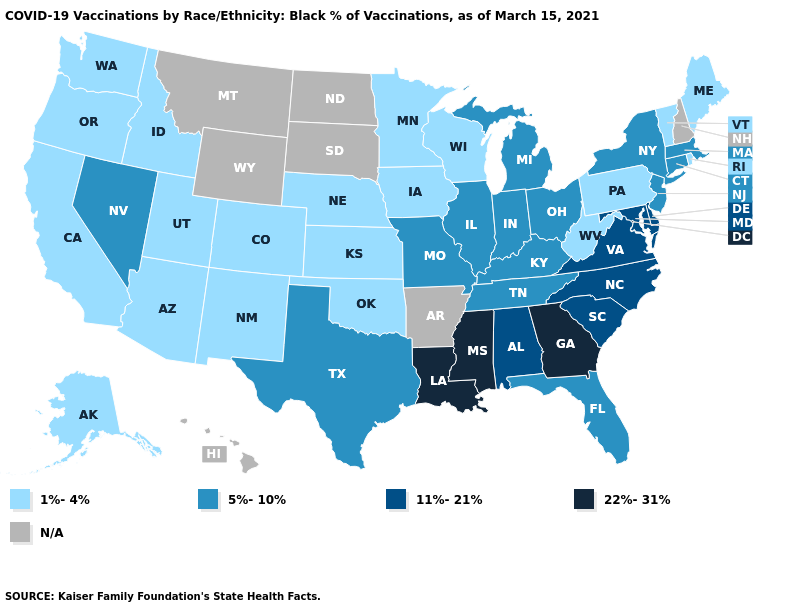Among the states that border Iowa , does Missouri have the highest value?
Keep it brief. Yes. What is the highest value in the USA?
Write a very short answer. 22%-31%. Does Arizona have the highest value in the USA?
Be succinct. No. Does Illinois have the lowest value in the MidWest?
Answer briefly. No. How many symbols are there in the legend?
Give a very brief answer. 5. What is the value of New Mexico?
Concise answer only. 1%-4%. Name the states that have a value in the range 11%-21%?
Concise answer only. Alabama, Delaware, Maryland, North Carolina, South Carolina, Virginia. What is the highest value in states that border Arizona?
Concise answer only. 5%-10%. Does Tennessee have the lowest value in the USA?
Concise answer only. No. How many symbols are there in the legend?
Answer briefly. 5. What is the lowest value in the MidWest?
Be succinct. 1%-4%. Does Mississippi have the highest value in the USA?
Be succinct. Yes. What is the highest value in the South ?
Short answer required. 22%-31%. What is the lowest value in states that border Oregon?
Give a very brief answer. 1%-4%. What is the value of Vermont?
Answer briefly. 1%-4%. 